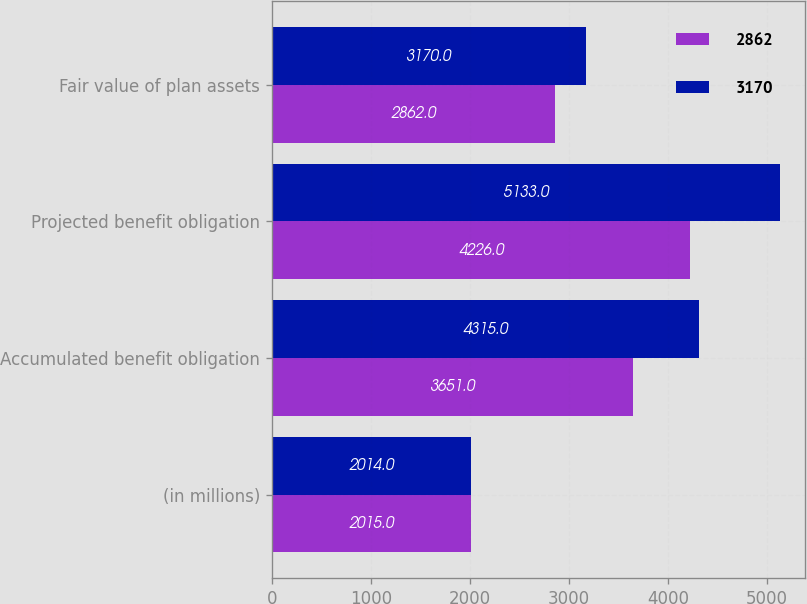Convert chart to OTSL. <chart><loc_0><loc_0><loc_500><loc_500><stacked_bar_chart><ecel><fcel>(in millions)<fcel>Accumulated benefit obligation<fcel>Projected benefit obligation<fcel>Fair value of plan assets<nl><fcel>2862<fcel>2015<fcel>3651<fcel>4226<fcel>2862<nl><fcel>3170<fcel>2014<fcel>4315<fcel>5133<fcel>3170<nl></chart> 